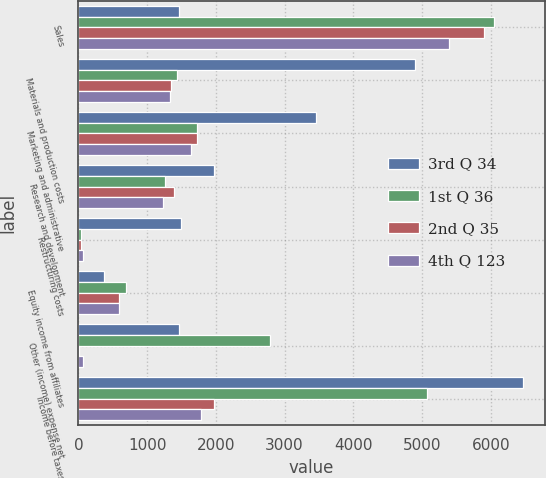Convert chart to OTSL. <chart><loc_0><loc_0><loc_500><loc_500><stacked_bar_chart><ecel><fcel>Sales<fcel>Materials and production costs<fcel>Marketing and administrative<fcel>Research and development<fcel>Restructuring costs<fcel>Equity income from affiliates<fcel>Other (income) expense net<fcel>Income before taxes<nl><fcel>3rd Q 34<fcel>1460.05<fcel>4900.8<fcel>3455.2<fcel>1971.5<fcel>1489.8<fcel>373.8<fcel>1460.05<fcel>6464.8<nl><fcel>1st Q 36<fcel>6049.7<fcel>1430.3<fcel>1725.5<fcel>1254<fcel>42.4<fcel>688.2<fcel>2791.1<fcel>5076.8<nl><fcel>2nd Q 35<fcel>5899.9<fcel>1353.9<fcel>1729.5<fcel>1395.3<fcel>37.4<fcel>587.1<fcel>3.6<fcel>1967.3<nl><fcel>4th Q 123<fcel>5385.2<fcel>1333.8<fcel>1632.9<fcel>1224.2<fcel>64.3<fcel>585.8<fcel>67.2<fcel>1783<nl></chart> 